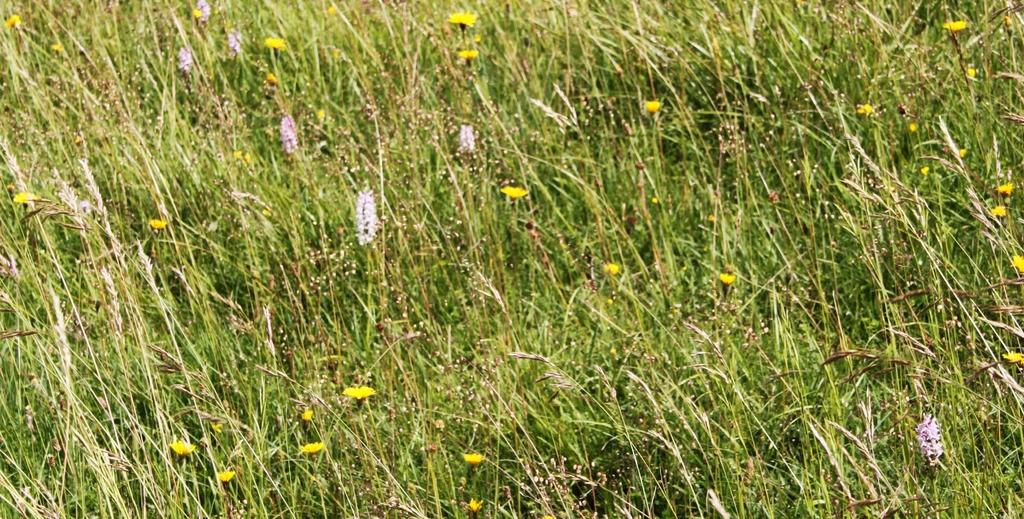What type of terrain is visible in the image? There is a grass field in the image. What type of noise can be heard coming from the sticks in the image? There are no sticks present in the image, so it is not possible to determine what, if any, noise might be heard. 